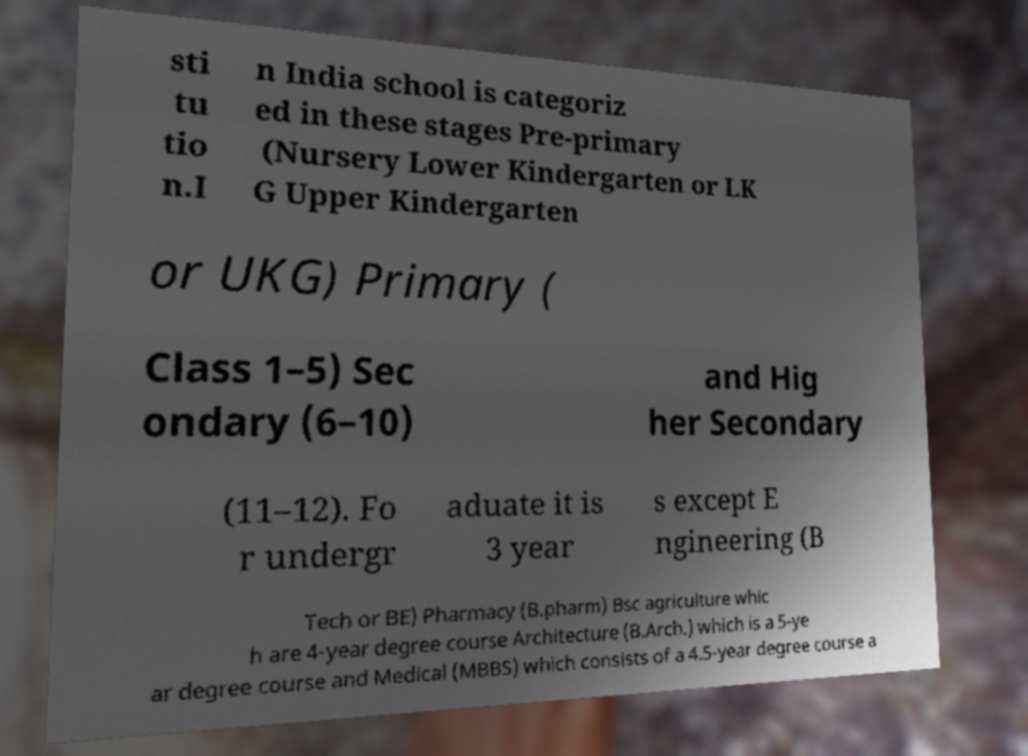Please read and relay the text visible in this image. What does it say? sti tu tio n.I n India school is categoriz ed in these stages Pre-primary (Nursery Lower Kindergarten or LK G Upper Kindergarten or UKG) Primary ( Class 1–5) Sec ondary (6–10) and Hig her Secondary (11–12). Fo r undergr aduate it is 3 year s except E ngineering (B Tech or BE) Pharmacy (B.pharm) Bsc agriculture whic h are 4-year degree course Architecture (B.Arch.) which is a 5-ye ar degree course and Medical (MBBS) which consists of a 4.5-year degree course a 